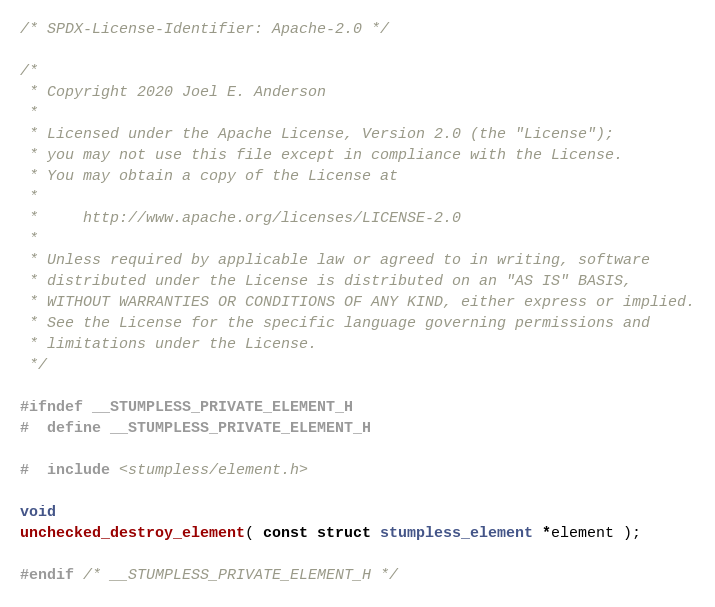Convert code to text. <code><loc_0><loc_0><loc_500><loc_500><_C_>/* SPDX-License-Identifier: Apache-2.0 */

/*
 * Copyright 2020 Joel E. Anderson
 *
 * Licensed under the Apache License, Version 2.0 (the "License");
 * you may not use this file except in compliance with the License.
 * You may obtain a copy of the License at
 *
 *     http://www.apache.org/licenses/LICENSE-2.0
 *
 * Unless required by applicable law or agreed to in writing, software
 * distributed under the License is distributed on an "AS IS" BASIS,
 * WITHOUT WARRANTIES OR CONDITIONS OF ANY KIND, either express or implied.
 * See the License for the specific language governing permissions and
 * limitations under the License.
 */

#ifndef __STUMPLESS_PRIVATE_ELEMENT_H
#  define __STUMPLESS_PRIVATE_ELEMENT_H

#  include <stumpless/element.h>

void
unchecked_destroy_element( const struct stumpless_element *element );

#endif /* __STUMPLESS_PRIVATE_ELEMENT_H */
</code> 